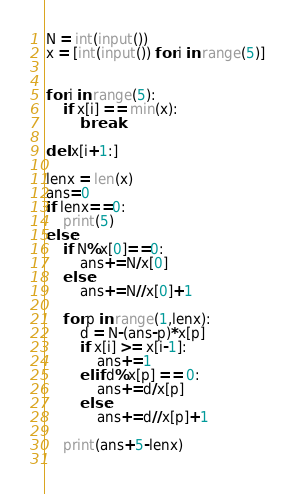Convert code to text. <code><loc_0><loc_0><loc_500><loc_500><_Python_>
N = int(input())
x = [int(input()) for i in range(5)]


for i in range(5):
    if x[i] == min(x):
        break
    
del x[i+1:]

lenx = len(x)
ans=0
if lenx==0:
    print(5)
else:
    if N%x[0]==0:
        ans+=N/x[0]
    else:
        ans+=N//x[0]+1

    for p in range(1,lenx):
        d = N-(ans-p)*x[p]
        if x[i] >= x[i-1]:
            ans+=1
        elif d%x[p] == 0:
            ans+=d/x[p]
        else:
            ans+=d//x[p]+1

    print(ans+5-lenx)
        </code> 